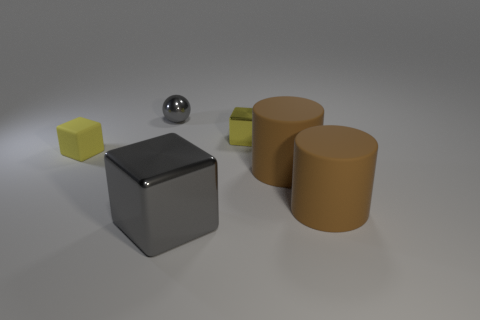Add 2 large metallic cubes. How many objects exist? 8 Subtract all cylinders. How many objects are left? 4 Subtract all metal objects. Subtract all large brown metallic spheres. How many objects are left? 3 Add 5 yellow rubber cubes. How many yellow rubber cubes are left? 6 Add 4 brown rubber cylinders. How many brown rubber cylinders exist? 6 Subtract 1 gray spheres. How many objects are left? 5 